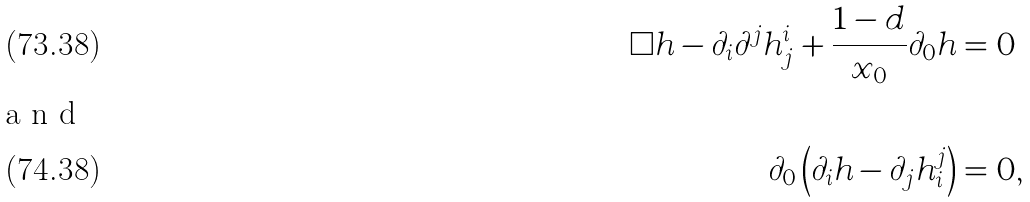Convert formula to latex. <formula><loc_0><loc_0><loc_500><loc_500>\Box h - \partial _ { i } \partial ^ { j } h ^ { i } _ { j } + \frac { 1 - d } { x _ { 0 } } \partial _ { 0 } h & = 0 \\ \intertext { a n d } \partial _ { 0 } \left ( \partial _ { i } h - \partial _ { j } h ^ { j } _ { i } \right ) & = 0 ,</formula> 